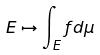<formula> <loc_0><loc_0><loc_500><loc_500>E \mapsto \int _ { E } f d \mu</formula> 